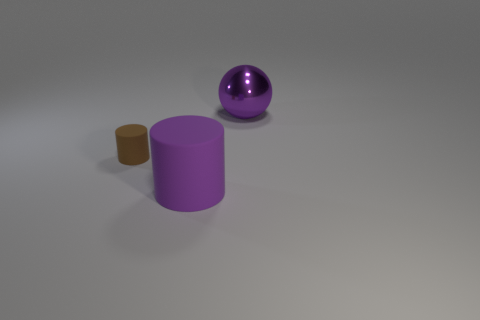Are there any other things that have the same size as the brown cylinder?
Ensure brevity in your answer.  No. What is the color of the other thing that is the same shape as the big purple rubber thing?
Offer a terse response. Brown. Is the shape of the metallic object the same as the small brown object?
Your answer should be compact. No. There is a purple matte object that is the same shape as the brown thing; what size is it?
Provide a succinct answer. Large. How many spheres are the same material as the big purple cylinder?
Keep it short and to the point. 0. What number of things are large spheres or brown cylinders?
Keep it short and to the point. 2. Is there a cylinder that is behind the purple object on the left side of the big ball?
Provide a succinct answer. Yes. Are there more purple objects that are on the right side of the big purple cylinder than brown matte cylinders behind the purple metal ball?
Keep it short and to the point. Yes. There is a thing that is the same color as the large matte cylinder; what is it made of?
Offer a very short reply. Metal. What number of other large cylinders have the same color as the big rubber cylinder?
Your response must be concise. 0. 